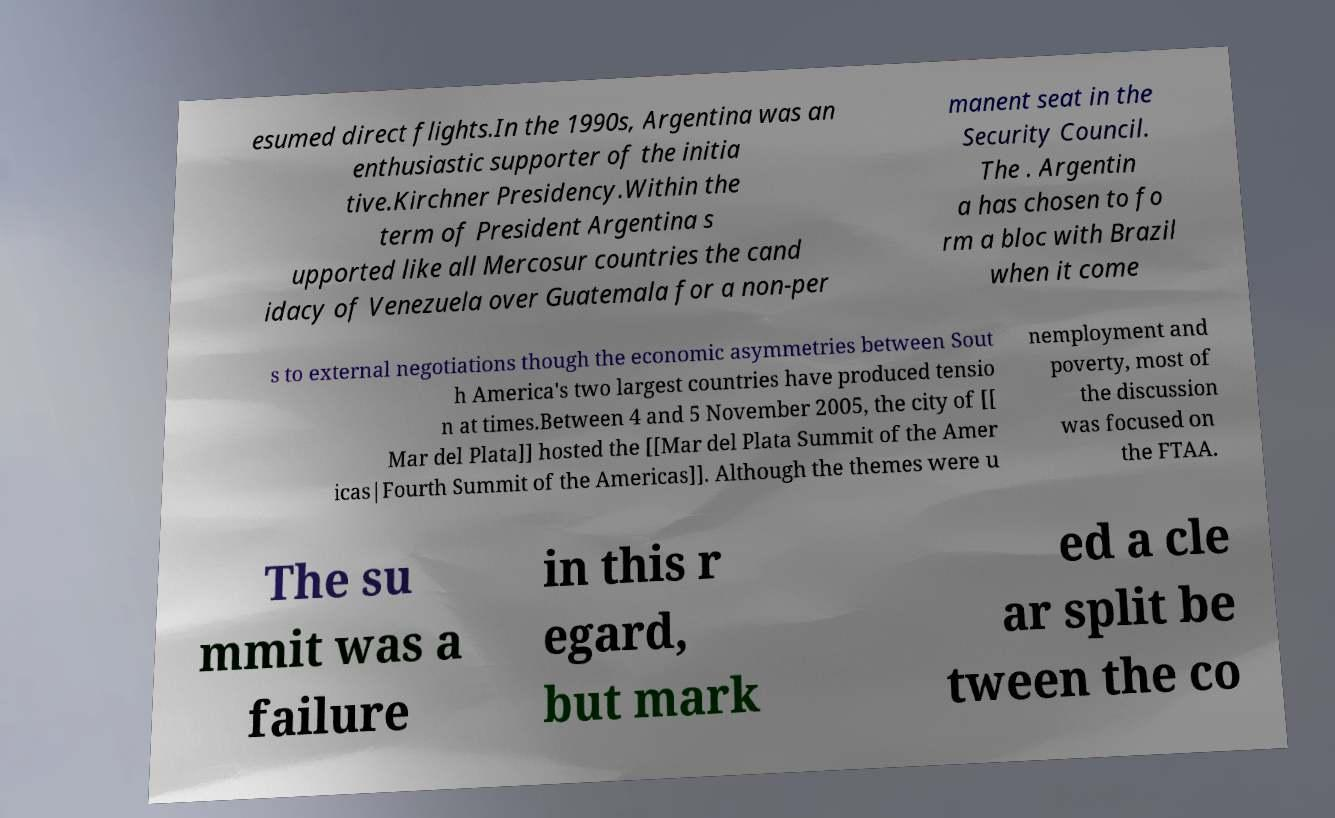Could you assist in decoding the text presented in this image and type it out clearly? esumed direct flights.In the 1990s, Argentina was an enthusiastic supporter of the initia tive.Kirchner Presidency.Within the term of President Argentina s upported like all Mercosur countries the cand idacy of Venezuela over Guatemala for a non-per manent seat in the Security Council. The . Argentin a has chosen to fo rm a bloc with Brazil when it come s to external negotiations though the economic asymmetries between Sout h America's two largest countries have produced tensio n at times.Between 4 and 5 November 2005, the city of [[ Mar del Plata]] hosted the [[Mar del Plata Summit of the Amer icas|Fourth Summit of the Americas]]. Although the themes were u nemployment and poverty, most of the discussion was focused on the FTAA. The su mmit was a failure in this r egard, but mark ed a cle ar split be tween the co 